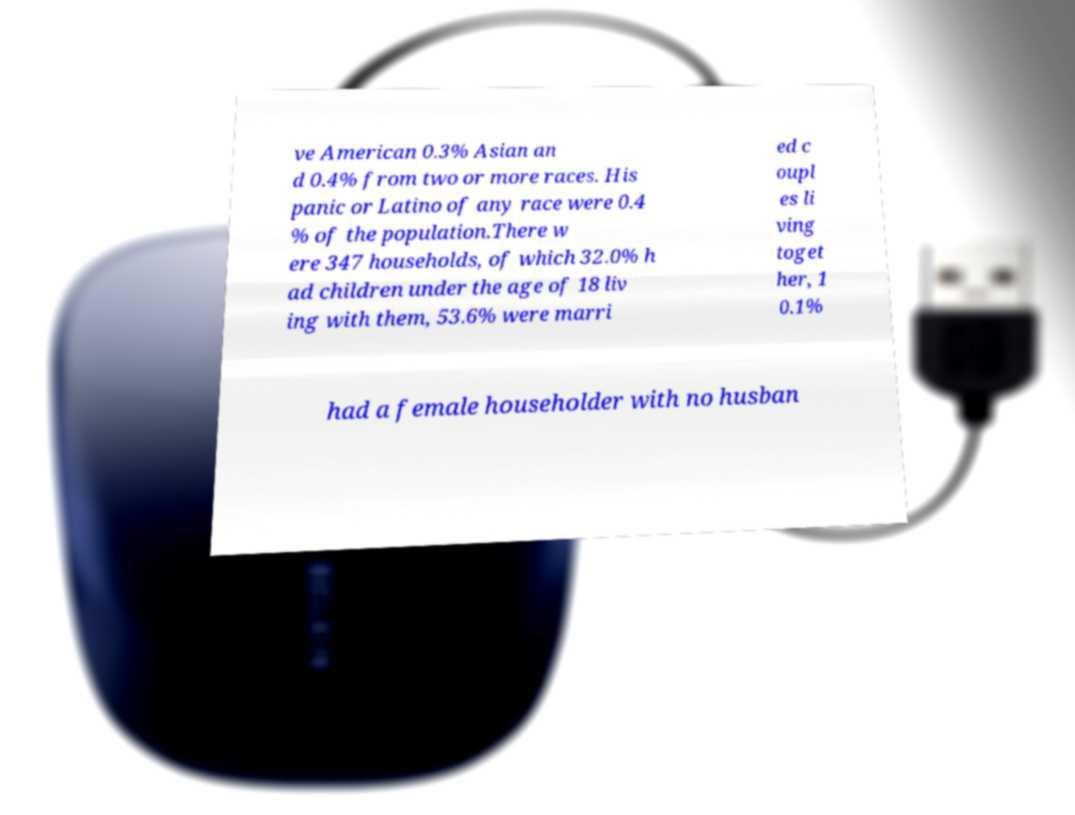For documentation purposes, I need the text within this image transcribed. Could you provide that? ve American 0.3% Asian an d 0.4% from two or more races. His panic or Latino of any race were 0.4 % of the population.There w ere 347 households, of which 32.0% h ad children under the age of 18 liv ing with them, 53.6% were marri ed c oupl es li ving toget her, 1 0.1% had a female householder with no husban 